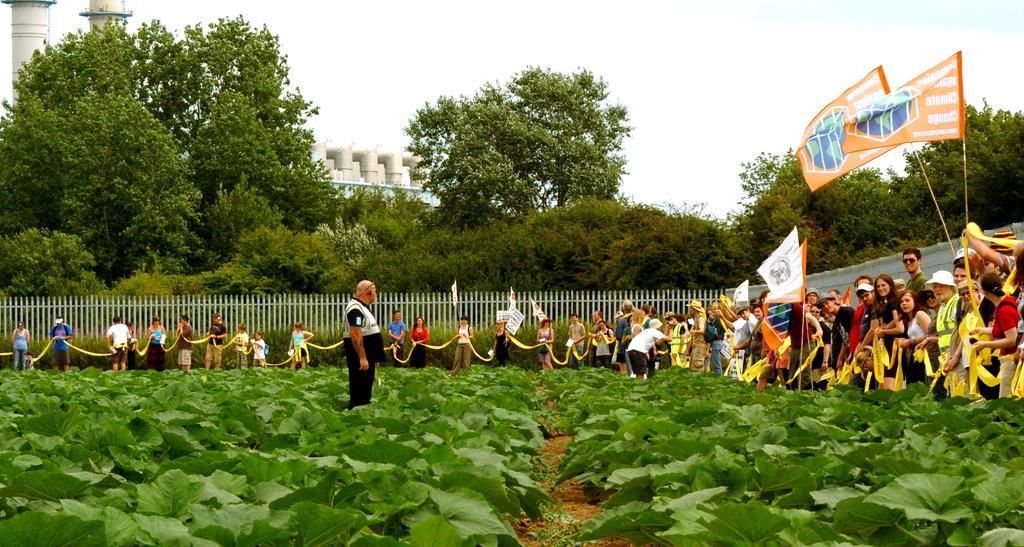Can you describe this image briefly? As we can see in the image there are few people here and there, plants, fence, flags, trees, buildings and sky. 